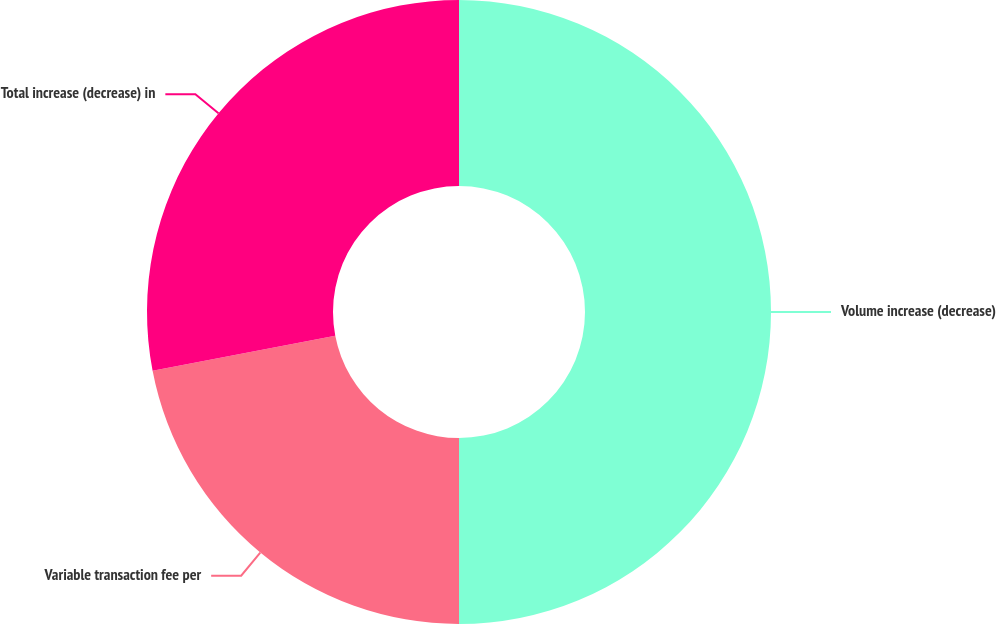Convert chart to OTSL. <chart><loc_0><loc_0><loc_500><loc_500><pie_chart><fcel>Volume increase (decrease)<fcel>Variable transaction fee per<fcel>Total increase (decrease) in<nl><fcel>50.0%<fcel>21.98%<fcel>28.02%<nl></chart> 